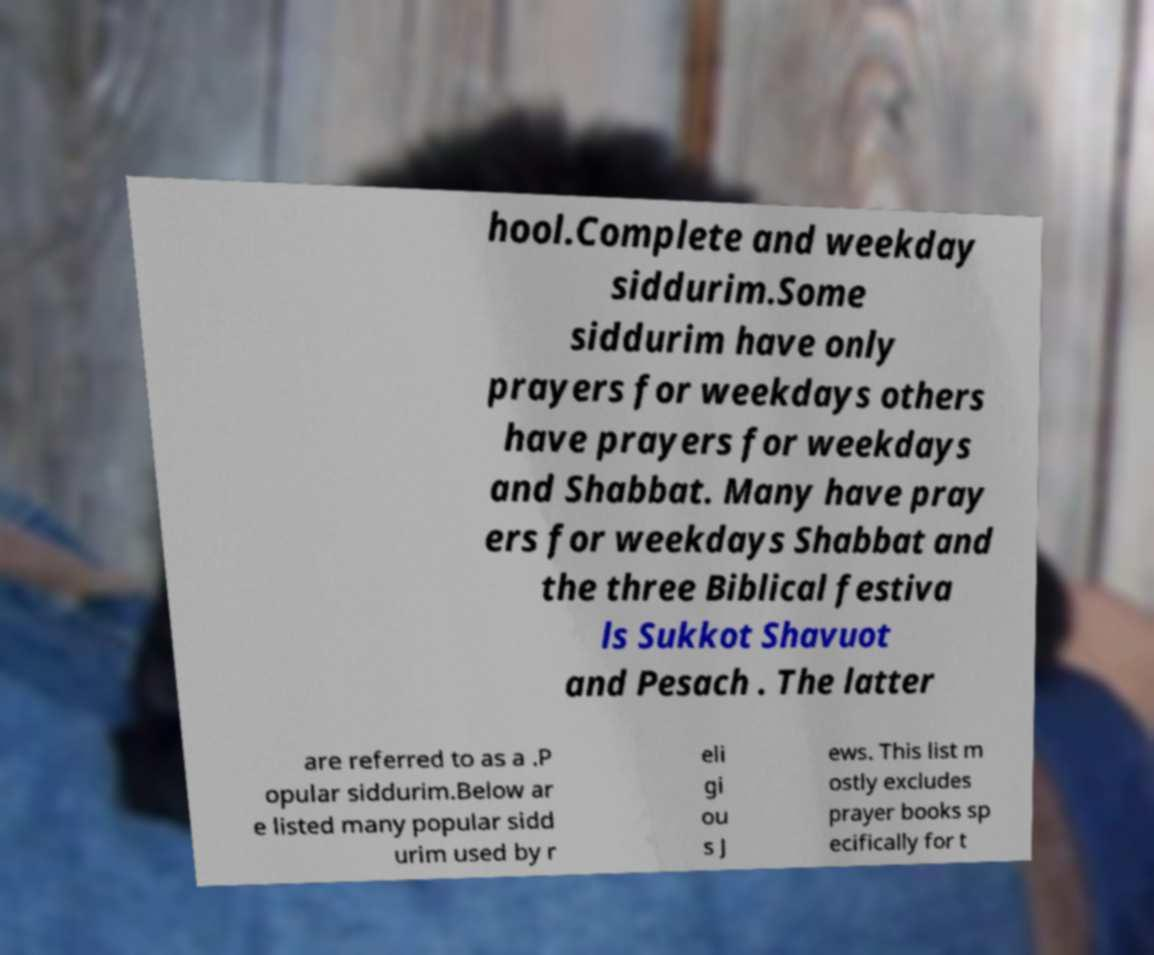For documentation purposes, I need the text within this image transcribed. Could you provide that? hool.Complete and weekday siddurim.Some siddurim have only prayers for weekdays others have prayers for weekdays and Shabbat. Many have pray ers for weekdays Shabbat and the three Biblical festiva ls Sukkot Shavuot and Pesach . The latter are referred to as a .P opular siddurim.Below ar e listed many popular sidd urim used by r eli gi ou s J ews. This list m ostly excludes prayer books sp ecifically for t 